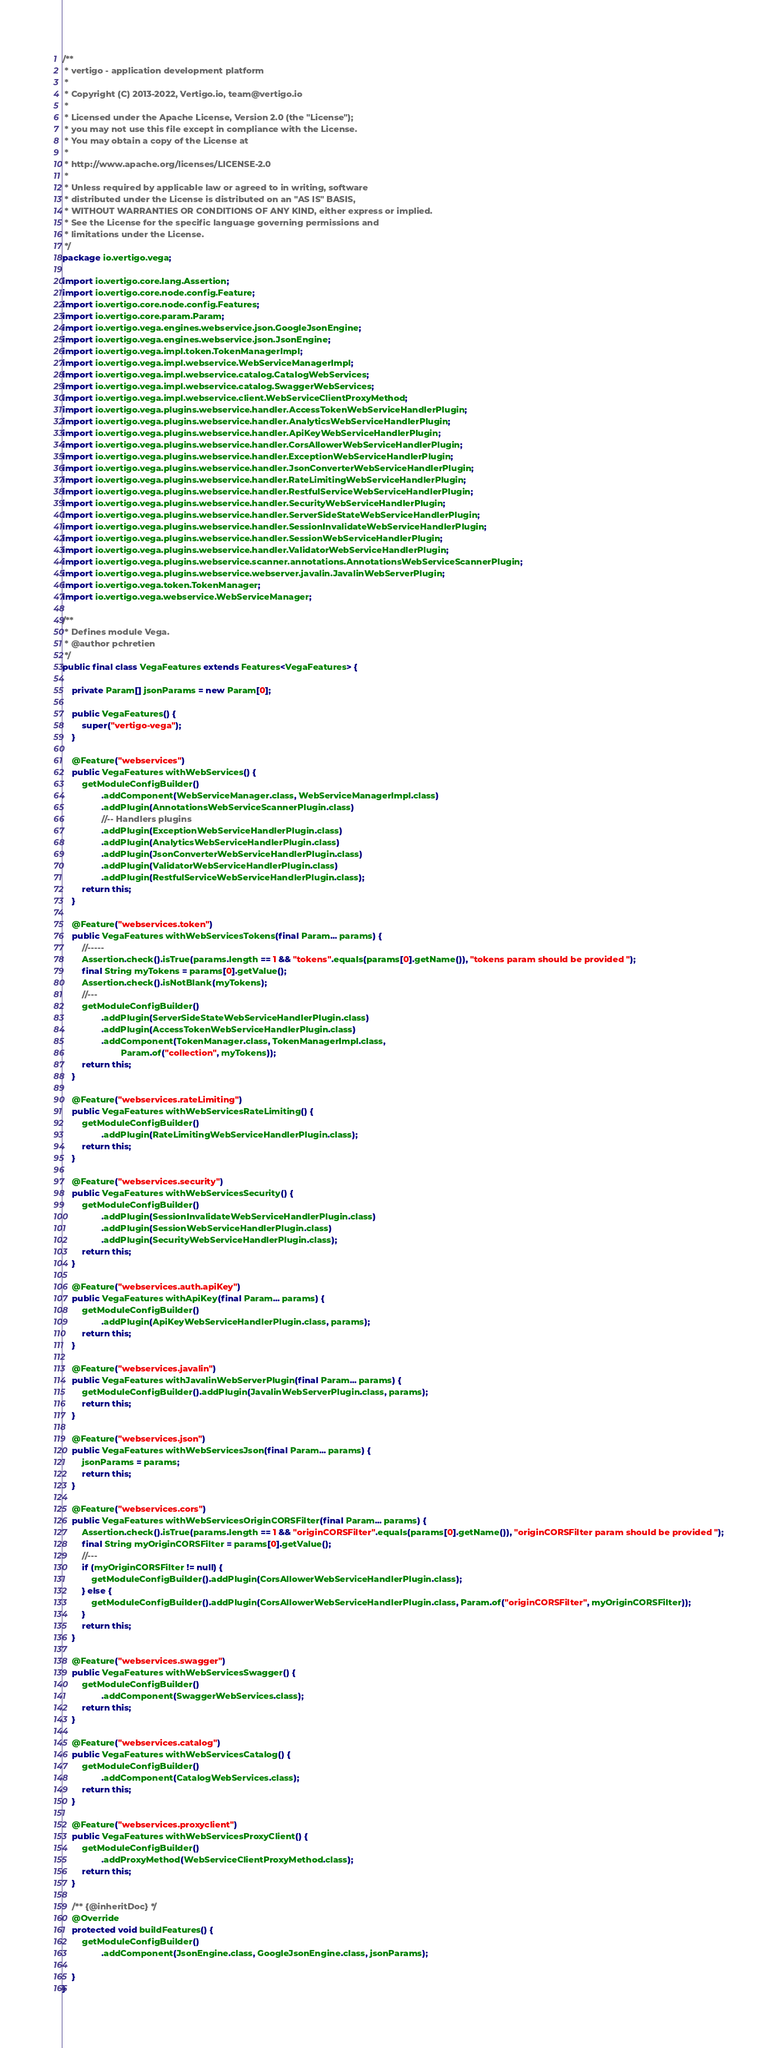<code> <loc_0><loc_0><loc_500><loc_500><_Java_>/**
 * vertigo - application development platform
 *
 * Copyright (C) 2013-2022, Vertigo.io, team@vertigo.io
 *
 * Licensed under the Apache License, Version 2.0 (the "License");
 * you may not use this file except in compliance with the License.
 * You may obtain a copy of the License at
 *
 * http://www.apache.org/licenses/LICENSE-2.0
 *
 * Unless required by applicable law or agreed to in writing, software
 * distributed under the License is distributed on an "AS IS" BASIS,
 * WITHOUT WARRANTIES OR CONDITIONS OF ANY KIND, either express or implied.
 * See the License for the specific language governing permissions and
 * limitations under the License.
 */
package io.vertigo.vega;

import io.vertigo.core.lang.Assertion;
import io.vertigo.core.node.config.Feature;
import io.vertigo.core.node.config.Features;
import io.vertigo.core.param.Param;
import io.vertigo.vega.engines.webservice.json.GoogleJsonEngine;
import io.vertigo.vega.engines.webservice.json.JsonEngine;
import io.vertigo.vega.impl.token.TokenManagerImpl;
import io.vertigo.vega.impl.webservice.WebServiceManagerImpl;
import io.vertigo.vega.impl.webservice.catalog.CatalogWebServices;
import io.vertigo.vega.impl.webservice.catalog.SwaggerWebServices;
import io.vertigo.vega.impl.webservice.client.WebServiceClientProxyMethod;
import io.vertigo.vega.plugins.webservice.handler.AccessTokenWebServiceHandlerPlugin;
import io.vertigo.vega.plugins.webservice.handler.AnalyticsWebServiceHandlerPlugin;
import io.vertigo.vega.plugins.webservice.handler.ApiKeyWebServiceHandlerPlugin;
import io.vertigo.vega.plugins.webservice.handler.CorsAllowerWebServiceHandlerPlugin;
import io.vertigo.vega.plugins.webservice.handler.ExceptionWebServiceHandlerPlugin;
import io.vertigo.vega.plugins.webservice.handler.JsonConverterWebServiceHandlerPlugin;
import io.vertigo.vega.plugins.webservice.handler.RateLimitingWebServiceHandlerPlugin;
import io.vertigo.vega.plugins.webservice.handler.RestfulServiceWebServiceHandlerPlugin;
import io.vertigo.vega.plugins.webservice.handler.SecurityWebServiceHandlerPlugin;
import io.vertigo.vega.plugins.webservice.handler.ServerSideStateWebServiceHandlerPlugin;
import io.vertigo.vega.plugins.webservice.handler.SessionInvalidateWebServiceHandlerPlugin;
import io.vertigo.vega.plugins.webservice.handler.SessionWebServiceHandlerPlugin;
import io.vertigo.vega.plugins.webservice.handler.ValidatorWebServiceHandlerPlugin;
import io.vertigo.vega.plugins.webservice.scanner.annotations.AnnotationsWebServiceScannerPlugin;
import io.vertigo.vega.plugins.webservice.webserver.javalin.JavalinWebServerPlugin;
import io.vertigo.vega.token.TokenManager;
import io.vertigo.vega.webservice.WebServiceManager;

/**
 * Defines module Vega.
 * @author pchretien
 */
public final class VegaFeatures extends Features<VegaFeatures> {

	private Param[] jsonParams = new Param[0];

	public VegaFeatures() {
		super("vertigo-vega");
	}

	@Feature("webservices")
	public VegaFeatures withWebServices() {
		getModuleConfigBuilder()
				.addComponent(WebServiceManager.class, WebServiceManagerImpl.class)
				.addPlugin(AnnotationsWebServiceScannerPlugin.class)
				//-- Handlers plugins
				.addPlugin(ExceptionWebServiceHandlerPlugin.class)
				.addPlugin(AnalyticsWebServiceHandlerPlugin.class)
				.addPlugin(JsonConverterWebServiceHandlerPlugin.class)
				.addPlugin(ValidatorWebServiceHandlerPlugin.class)
				.addPlugin(RestfulServiceWebServiceHandlerPlugin.class);
		return this;
	}

	@Feature("webservices.token")
	public VegaFeatures withWebServicesTokens(final Param... params) {
		//-----
		Assertion.check().isTrue(params.length == 1 && "tokens".equals(params[0].getName()), "tokens param should be provided ");
		final String myTokens = params[0].getValue();
		Assertion.check().isNotBlank(myTokens);
		//---
		getModuleConfigBuilder()
				.addPlugin(ServerSideStateWebServiceHandlerPlugin.class)
				.addPlugin(AccessTokenWebServiceHandlerPlugin.class)
				.addComponent(TokenManager.class, TokenManagerImpl.class,
						Param.of("collection", myTokens));
		return this;
	}

	@Feature("webservices.rateLimiting")
	public VegaFeatures withWebServicesRateLimiting() {
		getModuleConfigBuilder()
				.addPlugin(RateLimitingWebServiceHandlerPlugin.class);
		return this;
	}

	@Feature("webservices.security")
	public VegaFeatures withWebServicesSecurity() {
		getModuleConfigBuilder()
				.addPlugin(SessionInvalidateWebServiceHandlerPlugin.class)
				.addPlugin(SessionWebServiceHandlerPlugin.class)
				.addPlugin(SecurityWebServiceHandlerPlugin.class);
		return this;
	}

	@Feature("webservices.auth.apiKey")
	public VegaFeatures withApiKey(final Param... params) {
		getModuleConfigBuilder()
				.addPlugin(ApiKeyWebServiceHandlerPlugin.class, params);
		return this;
	}

	@Feature("webservices.javalin")
	public VegaFeatures withJavalinWebServerPlugin(final Param... params) {
		getModuleConfigBuilder().addPlugin(JavalinWebServerPlugin.class, params);
		return this;
	}

	@Feature("webservices.json")
	public VegaFeatures withWebServicesJson(final Param... params) {
		jsonParams = params;
		return this;
	}

	@Feature("webservices.cors")
	public VegaFeatures withWebServicesOriginCORSFilter(final Param... params) {
		Assertion.check().isTrue(params.length == 1 && "originCORSFilter".equals(params[0].getName()), "originCORSFilter param should be provided ");
		final String myOriginCORSFilter = params[0].getValue();
		//---
		if (myOriginCORSFilter != null) {
			getModuleConfigBuilder().addPlugin(CorsAllowerWebServiceHandlerPlugin.class);
		} else {
			getModuleConfigBuilder().addPlugin(CorsAllowerWebServiceHandlerPlugin.class, Param.of("originCORSFilter", myOriginCORSFilter));
		}
		return this;
	}

	@Feature("webservices.swagger")
	public VegaFeatures withWebServicesSwagger() {
		getModuleConfigBuilder()
				.addComponent(SwaggerWebServices.class);
		return this;
	}

	@Feature("webservices.catalog")
	public VegaFeatures withWebServicesCatalog() {
		getModuleConfigBuilder()
				.addComponent(CatalogWebServices.class);
		return this;
	}

	@Feature("webservices.proxyclient")
	public VegaFeatures withWebServicesProxyClient() {
		getModuleConfigBuilder()
				.addProxyMethod(WebServiceClientProxyMethod.class);
		return this;
	}

	/** {@inheritDoc} */
	@Override
	protected void buildFeatures() {
		getModuleConfigBuilder()
				.addComponent(JsonEngine.class, GoogleJsonEngine.class, jsonParams);

	}
}
</code> 